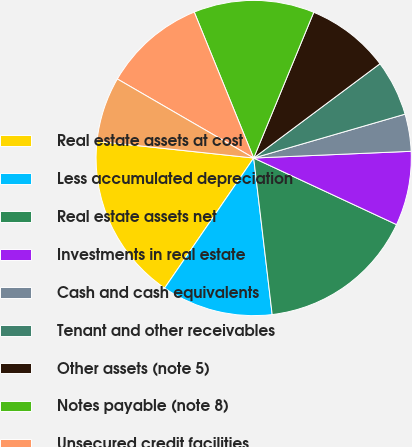Convert chart. <chart><loc_0><loc_0><loc_500><loc_500><pie_chart><fcel>Real estate assets at cost<fcel>Less accumulated depreciation<fcel>Real estate assets net<fcel>Investments in real estate<fcel>Cash and cash equivalents<fcel>Tenant and other receivables<fcel>Other assets (note 5)<fcel>Notes payable (note 8)<fcel>Unsecured credit facilities<fcel>Accounts payable and other<nl><fcel>17.14%<fcel>11.43%<fcel>16.19%<fcel>7.62%<fcel>3.81%<fcel>5.72%<fcel>8.57%<fcel>12.38%<fcel>10.48%<fcel>6.67%<nl></chart> 